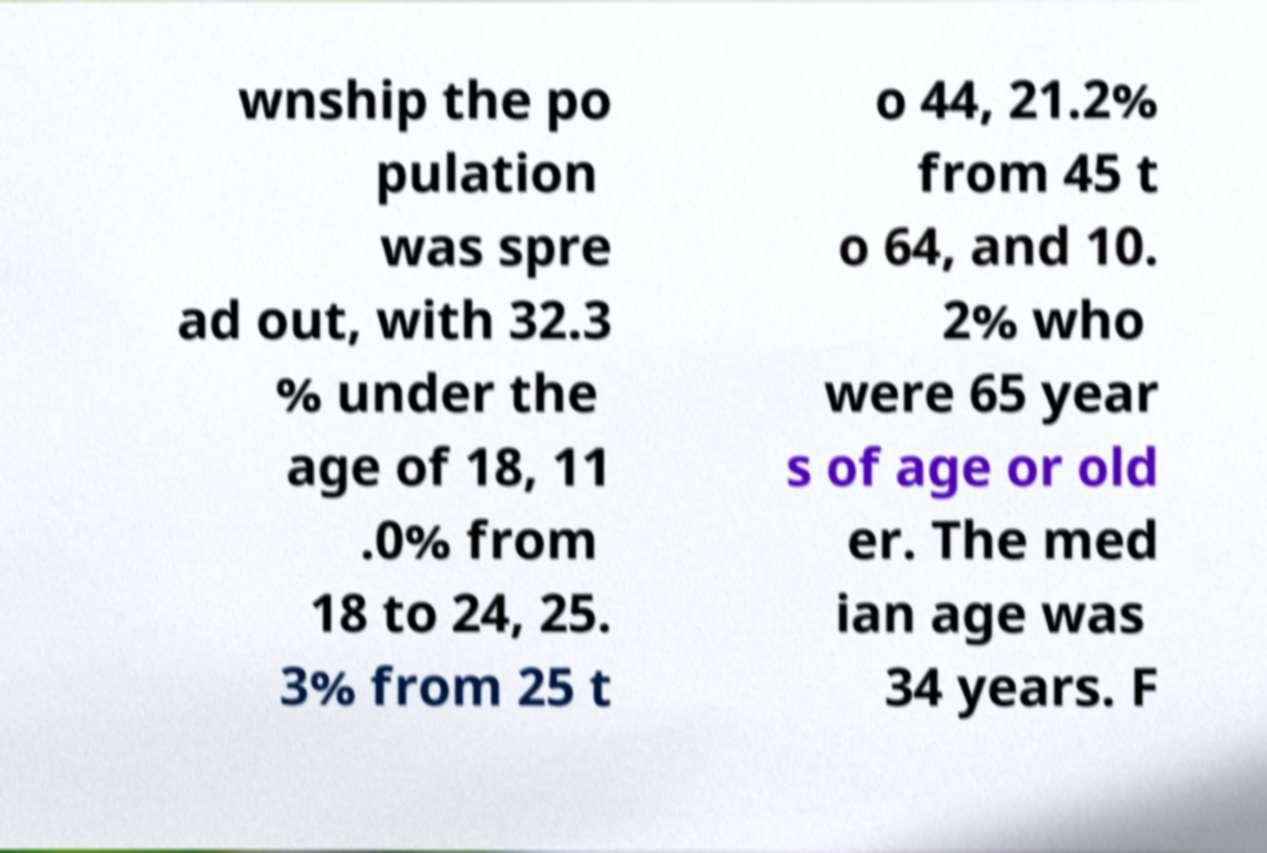I need the written content from this picture converted into text. Can you do that? wnship the po pulation was spre ad out, with 32.3 % under the age of 18, 11 .0% from 18 to 24, 25. 3% from 25 t o 44, 21.2% from 45 t o 64, and 10. 2% who were 65 year s of age or old er. The med ian age was 34 years. F 